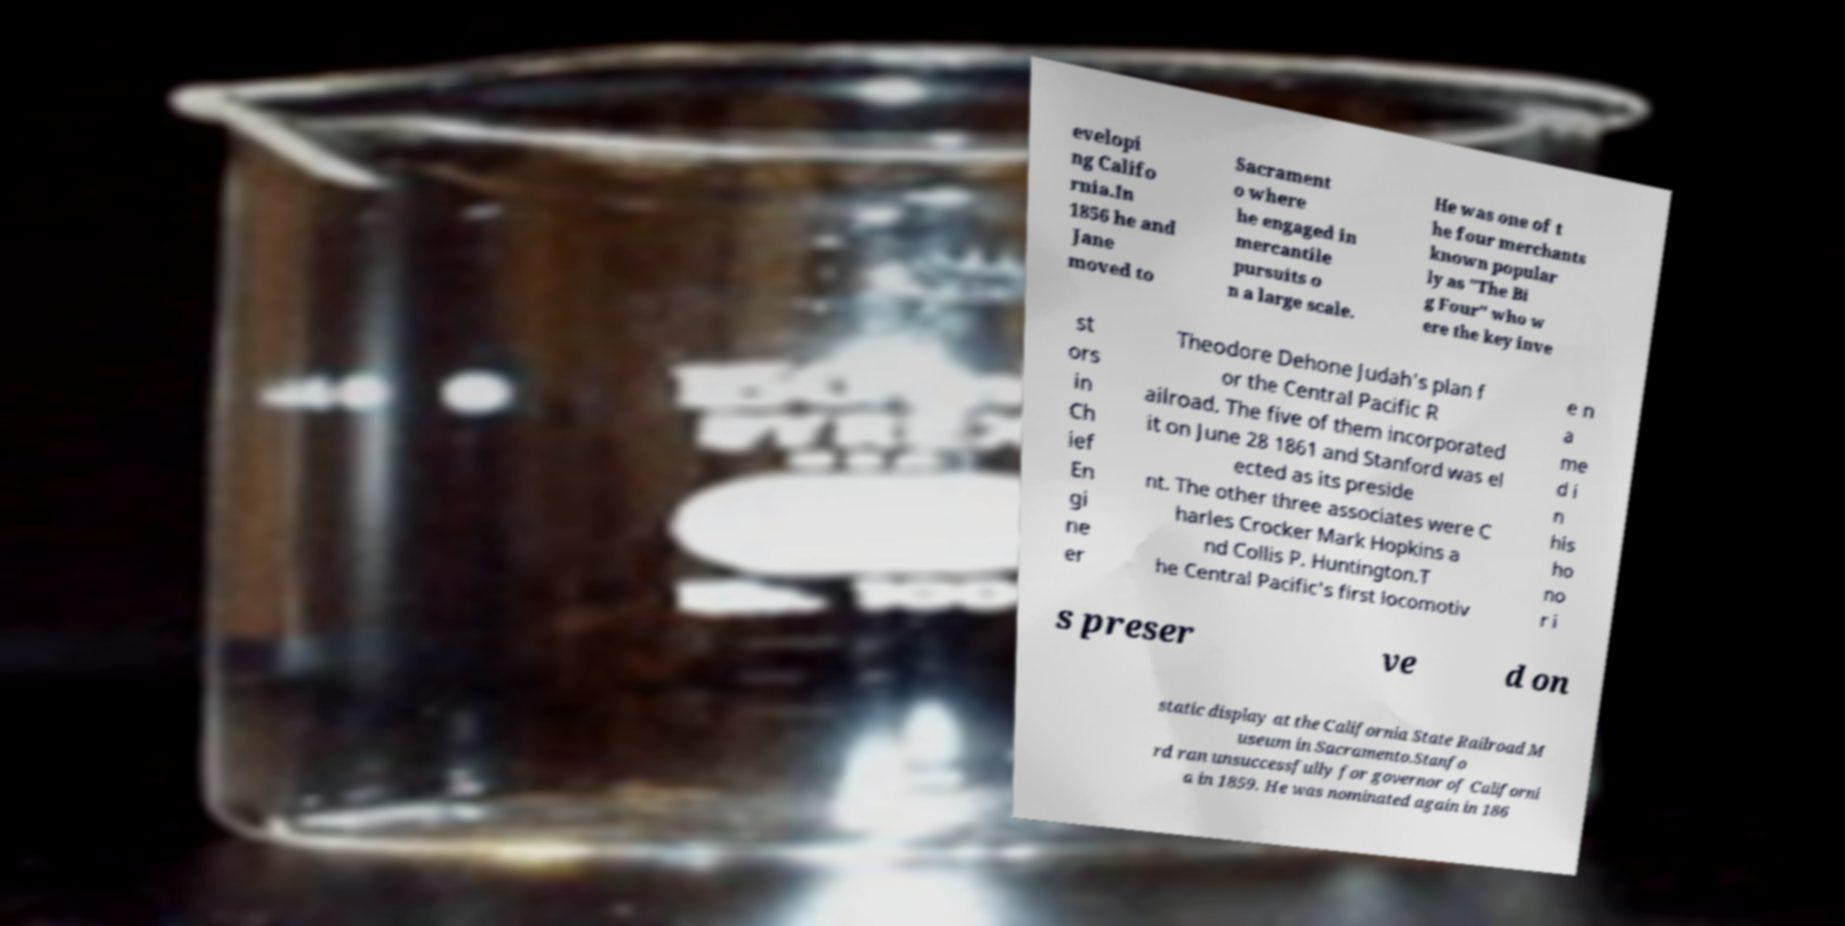There's text embedded in this image that I need extracted. Can you transcribe it verbatim? evelopi ng Califo rnia.In 1856 he and Jane moved to Sacrament o where he engaged in mercantile pursuits o n a large scale. He was one of t he four merchants known popular ly as "The Bi g Four" who w ere the key inve st ors in Ch ief En gi ne er Theodore Dehone Judah's plan f or the Central Pacific R ailroad. The five of them incorporated it on June 28 1861 and Stanford was el ected as its preside nt. The other three associates were C harles Crocker Mark Hopkins a nd Collis P. Huntington.T he Central Pacific's first locomotiv e n a me d i n his ho no r i s preser ve d on static display at the California State Railroad M useum in Sacramento.Stanfo rd ran unsuccessfully for governor of Californi a in 1859. He was nominated again in 186 